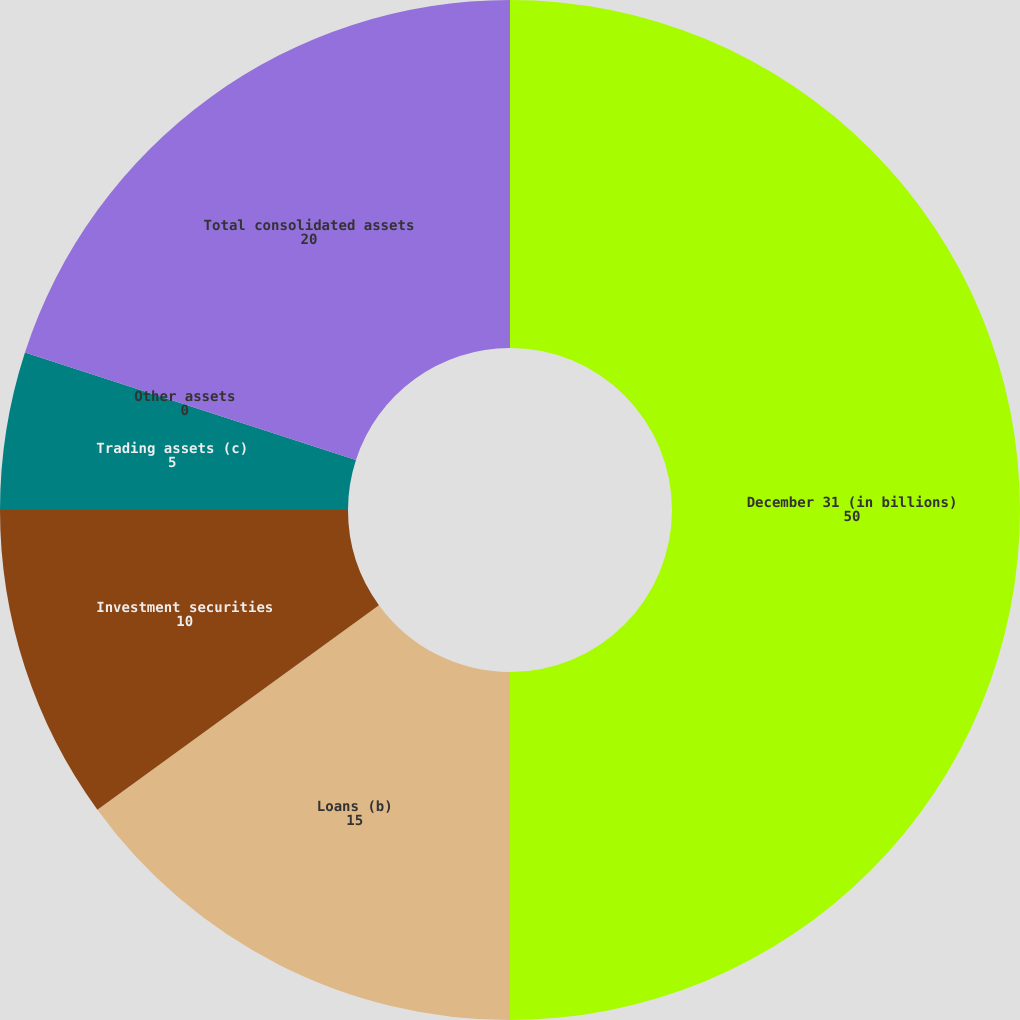<chart> <loc_0><loc_0><loc_500><loc_500><pie_chart><fcel>December 31 (in billions)<fcel>Loans (b)<fcel>Investment securities<fcel>Trading assets (c)<fcel>Other assets<fcel>Total consolidated assets<nl><fcel>50.0%<fcel>15.0%<fcel>10.0%<fcel>5.0%<fcel>0.0%<fcel>20.0%<nl></chart> 